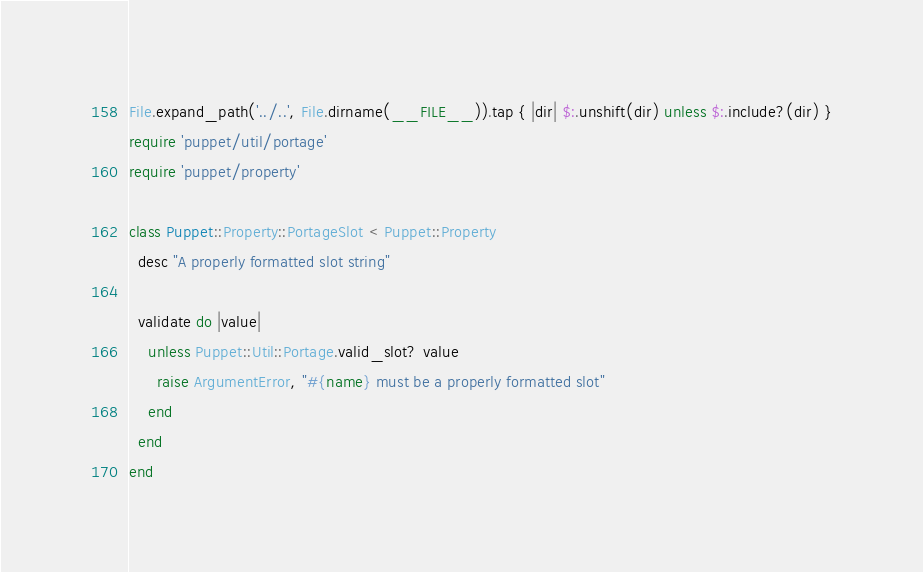Convert code to text. <code><loc_0><loc_0><loc_500><loc_500><_Ruby_>File.expand_path('../..', File.dirname(__FILE__)).tap { |dir| $:.unshift(dir) unless $:.include?(dir) }
require 'puppet/util/portage'
require 'puppet/property'

class Puppet::Property::PortageSlot < Puppet::Property
  desc "A properly formatted slot string"

  validate do |value|
    unless Puppet::Util::Portage.valid_slot? value
      raise ArgumentError, "#{name} must be a properly formatted slot"
    end
  end
end
</code> 